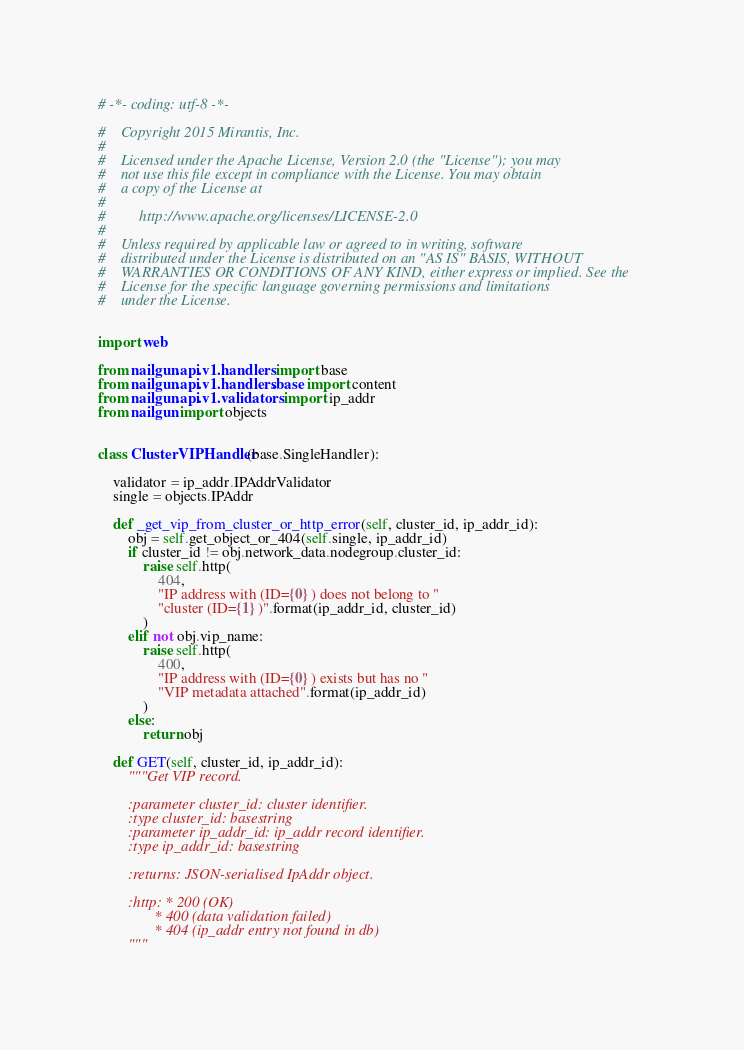<code> <loc_0><loc_0><loc_500><loc_500><_Python_># -*- coding: utf-8 -*-

#    Copyright 2015 Mirantis, Inc.
#
#    Licensed under the Apache License, Version 2.0 (the "License"); you may
#    not use this file except in compliance with the License. You may obtain
#    a copy of the License at
#
#         http://www.apache.org/licenses/LICENSE-2.0
#
#    Unless required by applicable law or agreed to in writing, software
#    distributed under the License is distributed on an "AS IS" BASIS, WITHOUT
#    WARRANTIES OR CONDITIONS OF ANY KIND, either express or implied. See the
#    License for the specific language governing permissions and limitations
#    under the License.


import web

from nailgun.api.v1.handlers import base
from nailgun.api.v1.handlers.base import content
from nailgun.api.v1.validators import ip_addr
from nailgun import objects


class ClusterVIPHandler(base.SingleHandler):

    validator = ip_addr.IPAddrValidator
    single = objects.IPAddr

    def _get_vip_from_cluster_or_http_error(self, cluster_id, ip_addr_id):
        obj = self.get_object_or_404(self.single, ip_addr_id)
        if cluster_id != obj.network_data.nodegroup.cluster_id:
            raise self.http(
                404,
                "IP address with (ID={0}) does not belong to "
                "cluster (ID={1})".format(ip_addr_id, cluster_id)
            )
        elif not obj.vip_name:
            raise self.http(
                400,
                "IP address with (ID={0}) exists but has no "
                "VIP metadata attached".format(ip_addr_id)
            )
        else:
            return obj

    def GET(self, cluster_id, ip_addr_id):
        """Get VIP record.

        :parameter cluster_id: cluster identifier.
        :type cluster_id: basestring
        :parameter ip_addr_id: ip_addr record identifier.
        :type ip_addr_id: basestring

        :returns: JSON-serialised IpAddr object.

        :http: * 200 (OK)
               * 400 (data validation failed)
               * 404 (ip_addr entry not found in db)
        """</code> 